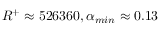<formula> <loc_0><loc_0><loc_500><loc_500>R ^ { + } \approx 5 2 6 3 6 0 , \alpha _ { \min } \approx 0 . 1 3</formula> 